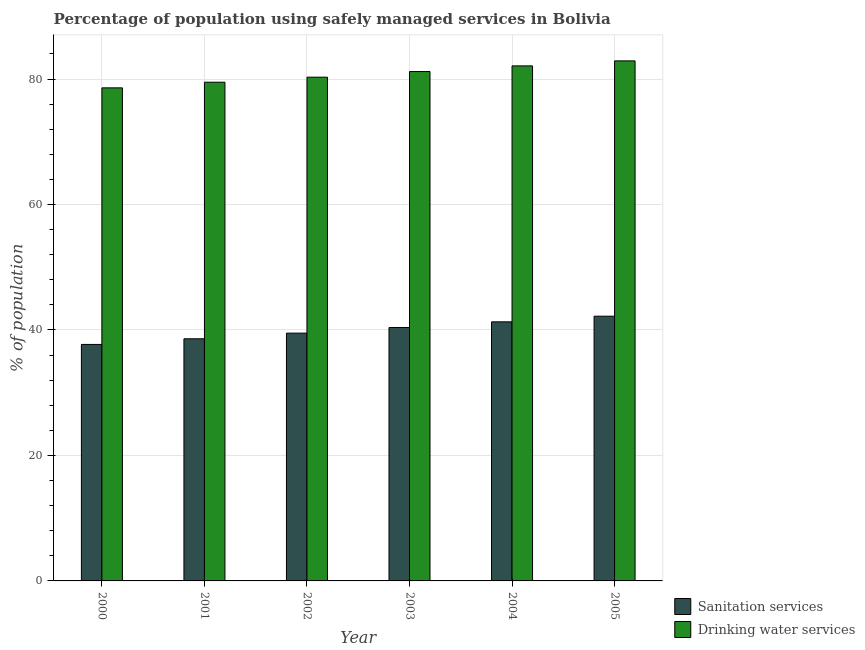How many groups of bars are there?
Ensure brevity in your answer.  6. What is the label of the 5th group of bars from the left?
Keep it short and to the point. 2004. In how many cases, is the number of bars for a given year not equal to the number of legend labels?
Ensure brevity in your answer.  0. What is the percentage of population who used sanitation services in 2005?
Your answer should be very brief. 42.2. Across all years, what is the maximum percentage of population who used drinking water services?
Your response must be concise. 82.9. Across all years, what is the minimum percentage of population who used drinking water services?
Give a very brief answer. 78.6. In which year was the percentage of population who used sanitation services minimum?
Your answer should be compact. 2000. What is the total percentage of population who used sanitation services in the graph?
Provide a succinct answer. 239.7. What is the difference between the percentage of population who used sanitation services in 2000 and that in 2004?
Offer a very short reply. -3.6. What is the difference between the percentage of population who used sanitation services in 2005 and the percentage of population who used drinking water services in 2001?
Make the answer very short. 3.6. What is the average percentage of population who used sanitation services per year?
Your answer should be compact. 39.95. What is the ratio of the percentage of population who used drinking water services in 2000 to that in 2005?
Your response must be concise. 0.95. Is the percentage of population who used sanitation services in 2000 less than that in 2005?
Your answer should be very brief. Yes. Is the difference between the percentage of population who used drinking water services in 2002 and 2003 greater than the difference between the percentage of population who used sanitation services in 2002 and 2003?
Provide a short and direct response. No. What is the difference between the highest and the second highest percentage of population who used drinking water services?
Make the answer very short. 0.8. In how many years, is the percentage of population who used sanitation services greater than the average percentage of population who used sanitation services taken over all years?
Your answer should be very brief. 3. Is the sum of the percentage of population who used sanitation services in 2001 and 2005 greater than the maximum percentage of population who used drinking water services across all years?
Give a very brief answer. Yes. What does the 2nd bar from the left in 2000 represents?
Keep it short and to the point. Drinking water services. What does the 1st bar from the right in 2000 represents?
Give a very brief answer. Drinking water services. How many bars are there?
Keep it short and to the point. 12. Are all the bars in the graph horizontal?
Make the answer very short. No. How many years are there in the graph?
Ensure brevity in your answer.  6. Are the values on the major ticks of Y-axis written in scientific E-notation?
Offer a very short reply. No. How many legend labels are there?
Make the answer very short. 2. What is the title of the graph?
Your response must be concise. Percentage of population using safely managed services in Bolivia. Does "Highest 10% of population" appear as one of the legend labels in the graph?
Make the answer very short. No. What is the label or title of the Y-axis?
Your response must be concise. % of population. What is the % of population in Sanitation services in 2000?
Ensure brevity in your answer.  37.7. What is the % of population in Drinking water services in 2000?
Keep it short and to the point. 78.6. What is the % of population in Sanitation services in 2001?
Ensure brevity in your answer.  38.6. What is the % of population of Drinking water services in 2001?
Ensure brevity in your answer.  79.5. What is the % of population of Sanitation services in 2002?
Your response must be concise. 39.5. What is the % of population of Drinking water services in 2002?
Provide a short and direct response. 80.3. What is the % of population in Sanitation services in 2003?
Your response must be concise. 40.4. What is the % of population of Drinking water services in 2003?
Ensure brevity in your answer.  81.2. What is the % of population of Sanitation services in 2004?
Offer a terse response. 41.3. What is the % of population of Drinking water services in 2004?
Give a very brief answer. 82.1. What is the % of population in Sanitation services in 2005?
Provide a short and direct response. 42.2. What is the % of population in Drinking water services in 2005?
Provide a succinct answer. 82.9. Across all years, what is the maximum % of population in Sanitation services?
Provide a succinct answer. 42.2. Across all years, what is the maximum % of population of Drinking water services?
Your response must be concise. 82.9. Across all years, what is the minimum % of population of Sanitation services?
Keep it short and to the point. 37.7. Across all years, what is the minimum % of population of Drinking water services?
Provide a short and direct response. 78.6. What is the total % of population in Sanitation services in the graph?
Offer a very short reply. 239.7. What is the total % of population in Drinking water services in the graph?
Provide a succinct answer. 484.6. What is the difference between the % of population of Sanitation services in 2000 and that in 2001?
Ensure brevity in your answer.  -0.9. What is the difference between the % of population of Sanitation services in 2000 and that in 2002?
Offer a terse response. -1.8. What is the difference between the % of population in Drinking water services in 2000 and that in 2002?
Your answer should be very brief. -1.7. What is the difference between the % of population of Sanitation services in 2000 and that in 2004?
Keep it short and to the point. -3.6. What is the difference between the % of population of Drinking water services in 2000 and that in 2004?
Keep it short and to the point. -3.5. What is the difference between the % of population of Sanitation services in 2000 and that in 2005?
Your answer should be very brief. -4.5. What is the difference between the % of population of Drinking water services in 2000 and that in 2005?
Give a very brief answer. -4.3. What is the difference between the % of population of Drinking water services in 2001 and that in 2002?
Your answer should be compact. -0.8. What is the difference between the % of population in Drinking water services in 2001 and that in 2004?
Make the answer very short. -2.6. What is the difference between the % of population in Drinking water services in 2001 and that in 2005?
Provide a succinct answer. -3.4. What is the difference between the % of population in Sanitation services in 2002 and that in 2003?
Offer a very short reply. -0.9. What is the difference between the % of population in Drinking water services in 2002 and that in 2003?
Provide a succinct answer. -0.9. What is the difference between the % of population of Sanitation services in 2002 and that in 2004?
Your response must be concise. -1.8. What is the difference between the % of population in Drinking water services in 2002 and that in 2004?
Provide a succinct answer. -1.8. What is the difference between the % of population of Sanitation services in 2002 and that in 2005?
Make the answer very short. -2.7. What is the difference between the % of population in Drinking water services in 2002 and that in 2005?
Provide a short and direct response. -2.6. What is the difference between the % of population in Sanitation services in 2003 and that in 2004?
Your answer should be very brief. -0.9. What is the difference between the % of population in Drinking water services in 2003 and that in 2004?
Provide a succinct answer. -0.9. What is the difference between the % of population of Drinking water services in 2003 and that in 2005?
Ensure brevity in your answer.  -1.7. What is the difference between the % of population of Sanitation services in 2004 and that in 2005?
Your response must be concise. -0.9. What is the difference between the % of population in Sanitation services in 2000 and the % of population in Drinking water services in 2001?
Your answer should be very brief. -41.8. What is the difference between the % of population of Sanitation services in 2000 and the % of population of Drinking water services in 2002?
Offer a very short reply. -42.6. What is the difference between the % of population of Sanitation services in 2000 and the % of population of Drinking water services in 2003?
Ensure brevity in your answer.  -43.5. What is the difference between the % of population in Sanitation services in 2000 and the % of population in Drinking water services in 2004?
Offer a very short reply. -44.4. What is the difference between the % of population of Sanitation services in 2000 and the % of population of Drinking water services in 2005?
Keep it short and to the point. -45.2. What is the difference between the % of population of Sanitation services in 2001 and the % of population of Drinking water services in 2002?
Provide a succinct answer. -41.7. What is the difference between the % of population of Sanitation services in 2001 and the % of population of Drinking water services in 2003?
Give a very brief answer. -42.6. What is the difference between the % of population in Sanitation services in 2001 and the % of population in Drinking water services in 2004?
Offer a very short reply. -43.5. What is the difference between the % of population in Sanitation services in 2001 and the % of population in Drinking water services in 2005?
Your answer should be very brief. -44.3. What is the difference between the % of population in Sanitation services in 2002 and the % of population in Drinking water services in 2003?
Your answer should be very brief. -41.7. What is the difference between the % of population of Sanitation services in 2002 and the % of population of Drinking water services in 2004?
Keep it short and to the point. -42.6. What is the difference between the % of population in Sanitation services in 2002 and the % of population in Drinking water services in 2005?
Keep it short and to the point. -43.4. What is the difference between the % of population in Sanitation services in 2003 and the % of population in Drinking water services in 2004?
Your answer should be compact. -41.7. What is the difference between the % of population of Sanitation services in 2003 and the % of population of Drinking water services in 2005?
Keep it short and to the point. -42.5. What is the difference between the % of population of Sanitation services in 2004 and the % of population of Drinking water services in 2005?
Your response must be concise. -41.6. What is the average % of population in Sanitation services per year?
Offer a very short reply. 39.95. What is the average % of population of Drinking water services per year?
Offer a very short reply. 80.77. In the year 2000, what is the difference between the % of population of Sanitation services and % of population of Drinking water services?
Provide a short and direct response. -40.9. In the year 2001, what is the difference between the % of population of Sanitation services and % of population of Drinking water services?
Offer a very short reply. -40.9. In the year 2002, what is the difference between the % of population in Sanitation services and % of population in Drinking water services?
Your response must be concise. -40.8. In the year 2003, what is the difference between the % of population in Sanitation services and % of population in Drinking water services?
Offer a very short reply. -40.8. In the year 2004, what is the difference between the % of population of Sanitation services and % of population of Drinking water services?
Offer a terse response. -40.8. In the year 2005, what is the difference between the % of population of Sanitation services and % of population of Drinking water services?
Keep it short and to the point. -40.7. What is the ratio of the % of population of Sanitation services in 2000 to that in 2001?
Your answer should be compact. 0.98. What is the ratio of the % of population of Drinking water services in 2000 to that in 2001?
Provide a succinct answer. 0.99. What is the ratio of the % of population in Sanitation services in 2000 to that in 2002?
Provide a succinct answer. 0.95. What is the ratio of the % of population of Drinking water services in 2000 to that in 2002?
Give a very brief answer. 0.98. What is the ratio of the % of population in Sanitation services in 2000 to that in 2003?
Your answer should be compact. 0.93. What is the ratio of the % of population in Drinking water services in 2000 to that in 2003?
Provide a succinct answer. 0.97. What is the ratio of the % of population in Sanitation services in 2000 to that in 2004?
Provide a short and direct response. 0.91. What is the ratio of the % of population in Drinking water services in 2000 to that in 2004?
Your response must be concise. 0.96. What is the ratio of the % of population in Sanitation services in 2000 to that in 2005?
Your response must be concise. 0.89. What is the ratio of the % of population in Drinking water services in 2000 to that in 2005?
Make the answer very short. 0.95. What is the ratio of the % of population of Sanitation services in 2001 to that in 2002?
Ensure brevity in your answer.  0.98. What is the ratio of the % of population in Sanitation services in 2001 to that in 2003?
Your answer should be very brief. 0.96. What is the ratio of the % of population in Drinking water services in 2001 to that in 2003?
Provide a succinct answer. 0.98. What is the ratio of the % of population in Sanitation services in 2001 to that in 2004?
Offer a very short reply. 0.93. What is the ratio of the % of population of Drinking water services in 2001 to that in 2004?
Make the answer very short. 0.97. What is the ratio of the % of population in Sanitation services in 2001 to that in 2005?
Give a very brief answer. 0.91. What is the ratio of the % of population in Sanitation services in 2002 to that in 2003?
Offer a terse response. 0.98. What is the ratio of the % of population of Drinking water services in 2002 to that in 2003?
Your response must be concise. 0.99. What is the ratio of the % of population in Sanitation services in 2002 to that in 2004?
Your answer should be very brief. 0.96. What is the ratio of the % of population in Drinking water services in 2002 to that in 2004?
Offer a very short reply. 0.98. What is the ratio of the % of population in Sanitation services in 2002 to that in 2005?
Give a very brief answer. 0.94. What is the ratio of the % of population of Drinking water services in 2002 to that in 2005?
Your answer should be very brief. 0.97. What is the ratio of the % of population in Sanitation services in 2003 to that in 2004?
Keep it short and to the point. 0.98. What is the ratio of the % of population in Sanitation services in 2003 to that in 2005?
Your answer should be compact. 0.96. What is the ratio of the % of population in Drinking water services in 2003 to that in 2005?
Keep it short and to the point. 0.98. What is the ratio of the % of population of Sanitation services in 2004 to that in 2005?
Ensure brevity in your answer.  0.98. What is the ratio of the % of population of Drinking water services in 2004 to that in 2005?
Make the answer very short. 0.99. What is the difference between the highest and the lowest % of population in Sanitation services?
Give a very brief answer. 4.5. 